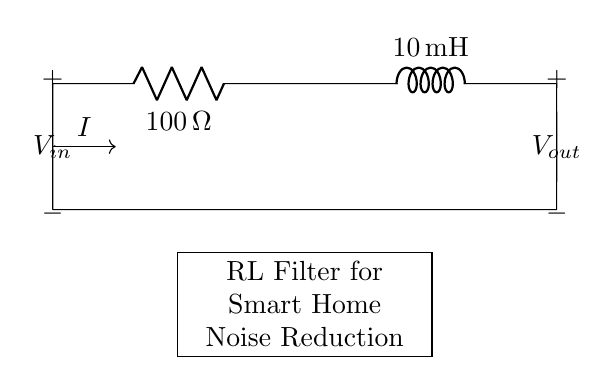What is the resistance value in this circuit? The circuit diagram shows a resistor labeled with the symbol R and it is marked with a value of 100 ohms.
Answer: 100 ohm What is the inductance of the inductor in this circuit? The diagram shows an inductor labeled with the symbol L, which has a value marked as 10 millihenries.
Answer: 10 millihenry How are the resistor and inductor connected in this circuit? The circuit shows that the resistor and inductor are connected in series, meaning the current flows through the resistor first and then through the inductor.
Answer: In series What is the role of the RL filter in a smart home system? An RL filter is used to reduce electrical noise by allowing the desired frequencies to pass while attenuating others, thus improving overall system performance.
Answer: Noise reduction What would happen to the output voltage if the resistance is increased? Increasing the resistance would reduce the current through the circuit, resulting in a lower output voltage across the load since voltage drop across the resistor increases.
Answer: Lower output voltage What is the input voltage in this circuit? The circuit diagram labels an open point at the input with v_in, but does not specify a numerical value; it generally indicates that the voltage source can vary.
Answer: Not specified What is the importance of using both a resistor and an inductor in this circuit? The combination of resistor and inductor in an RL filter creates a frequency-dependent impedance that effectively allows for selective attenuation of high-frequency noise while allowing low-frequency signals to pass, enhancing signal integrity.
Answer: Selective attenuation 